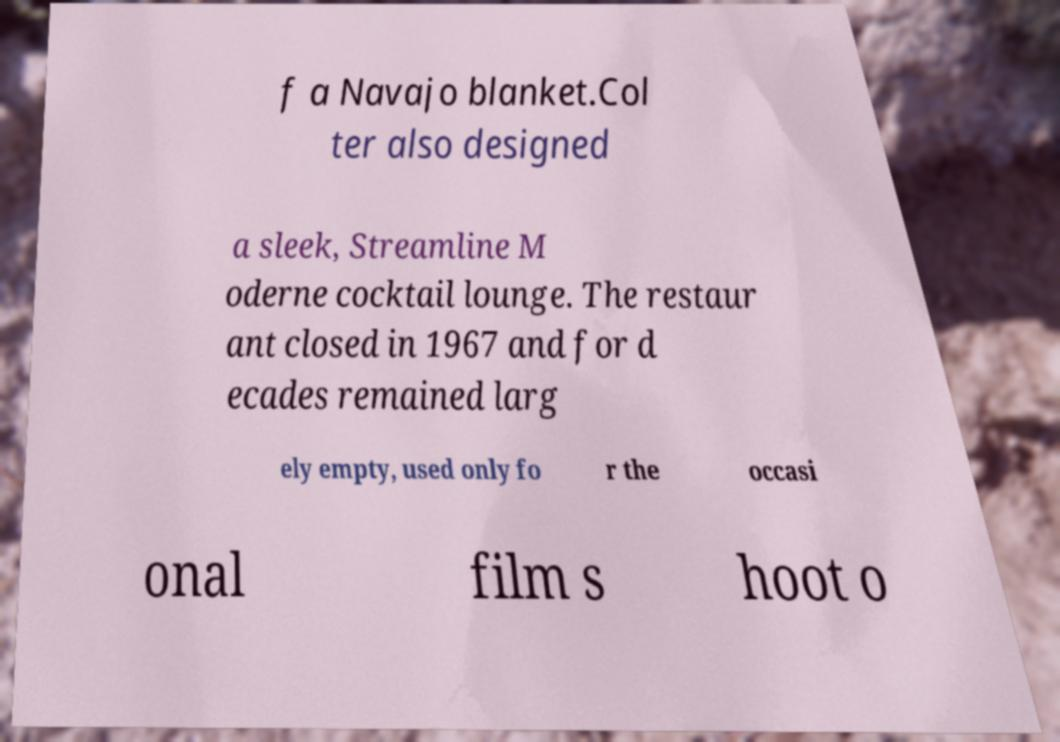Please read and relay the text visible in this image. What does it say? f a Navajo blanket.Col ter also designed a sleek, Streamline M oderne cocktail lounge. The restaur ant closed in 1967 and for d ecades remained larg ely empty, used only fo r the occasi onal film s hoot o 